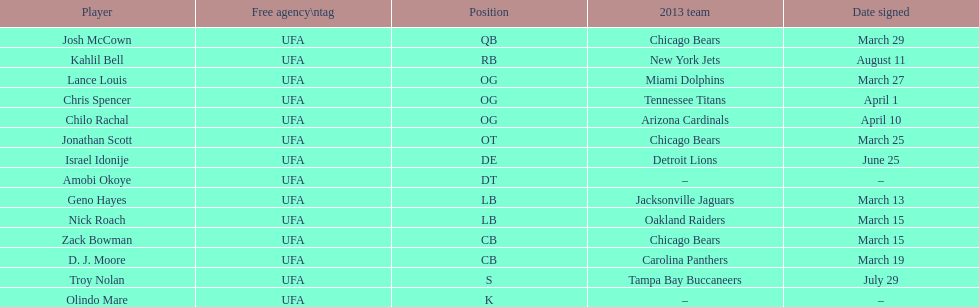Signed the same date as "april fools day". Chris Spencer. 